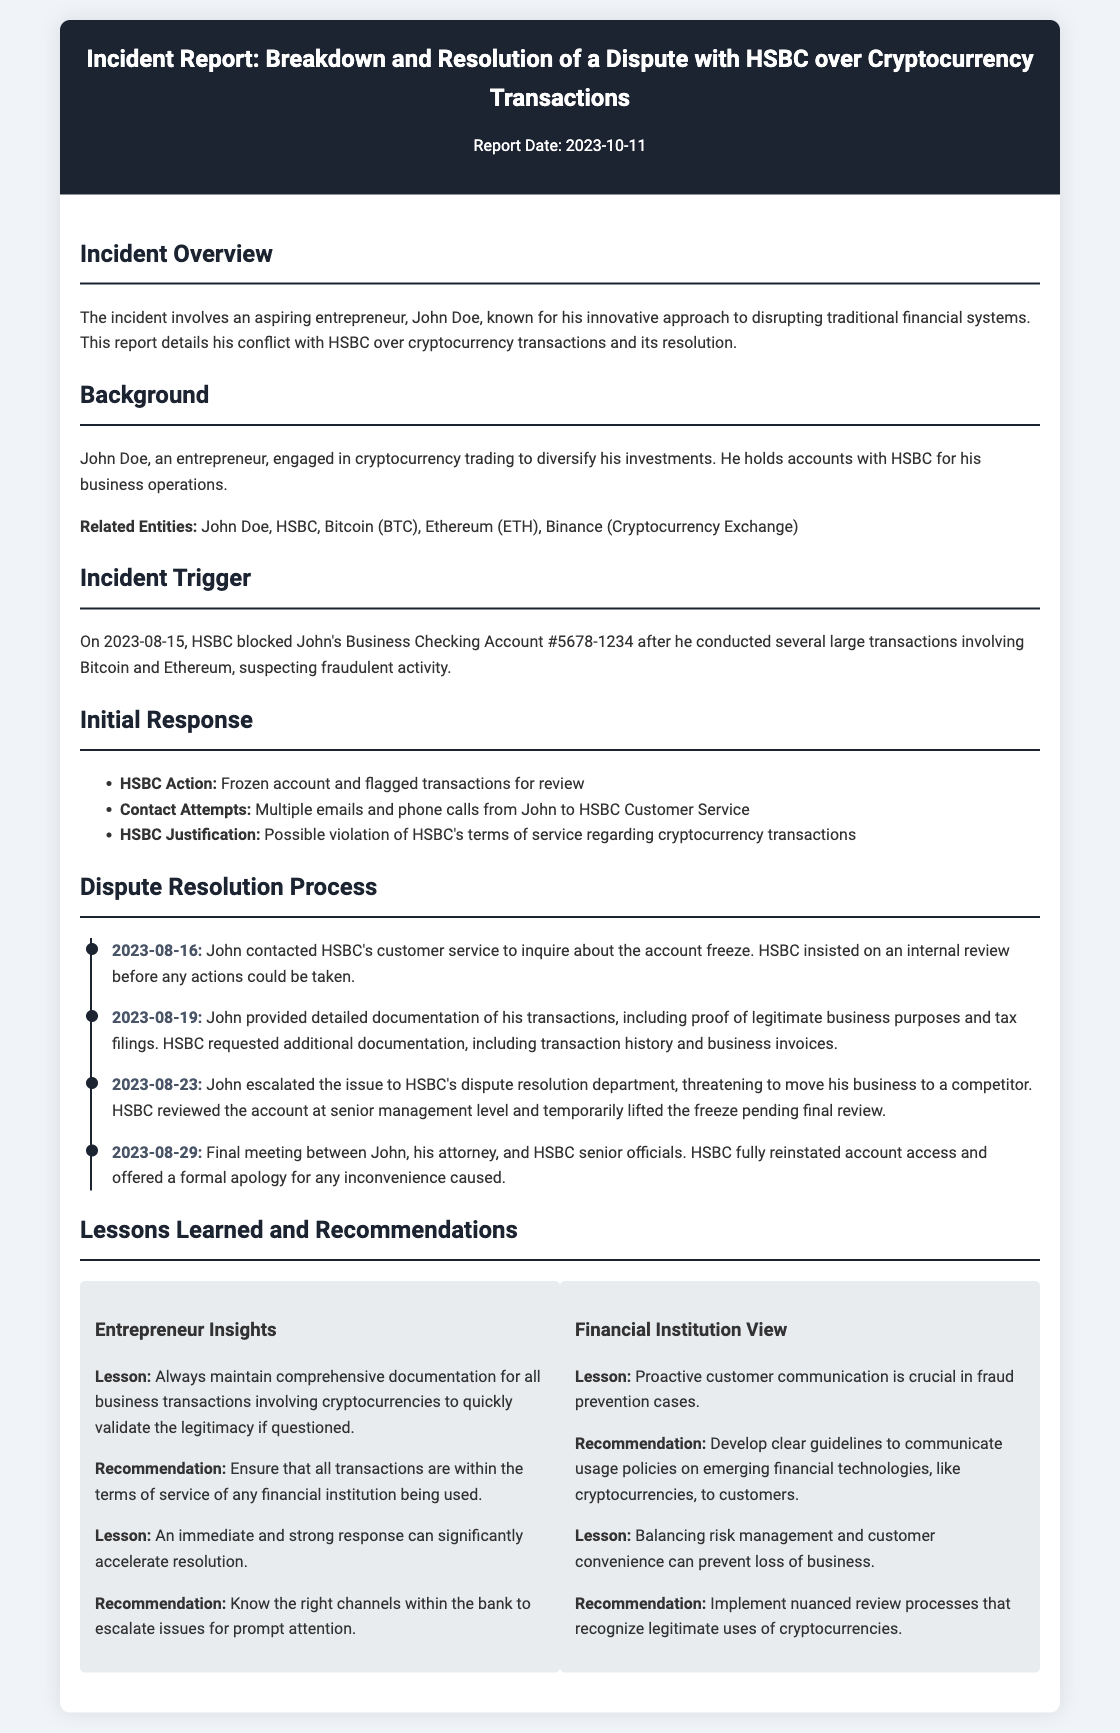what is the report date? The report date is mentioned in the header of the document as 2023-10-11.
Answer: 2023-10-11 who is the entrepreneur involved in the dispute? The document identifies the entrepreneur engaged in the dispute as John Doe.
Answer: John Doe what was the account status on 2023-08-15? The account status is noted as blocked after the large cryptocurrency transactions were conducted.
Answer: Blocked what did John provide on 2023-08-19? The document states that John provided detailed documentation of his transactions on this date.
Answer: Detailed documentation what was HSBC's action on 2023-08-16? HSBC froze John's account and flagged transactions for review as an initial response.
Answer: Frozen account what lesson is highlighted for entrepreneurs regarding documentation? The document emphasizes the importance of maintaining comprehensive documentation for validation of transactions.
Answer: Comprehensive documentation what does the final meeting on 2023-08-29 result in? This final meeting resulted in HSBC fully reinstating account access and offering an apology.
Answer: Reinstated account access and apology what is one recommendation for financial institutions noted in the report? The document recommends developing clear guidelines for communicating usage policies on cryptocurrencies.
Answer: Develop clear guidelines how many days did it take to resolve the dispute? The timeline indicates that the issue was resolved from the blocking date to final reinstatement, which took approximately 14 days.
Answer: 14 days 